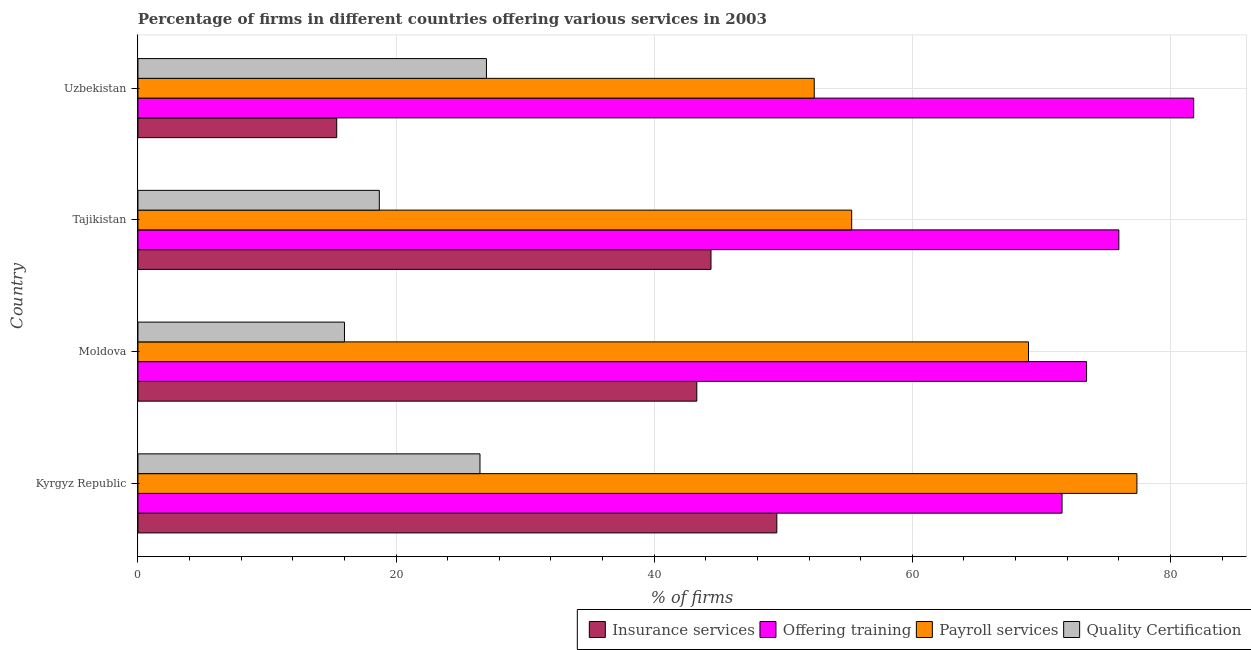How many different coloured bars are there?
Offer a very short reply. 4. Are the number of bars per tick equal to the number of legend labels?
Give a very brief answer. Yes. Are the number of bars on each tick of the Y-axis equal?
Ensure brevity in your answer.  Yes. How many bars are there on the 3rd tick from the top?
Your answer should be very brief. 4. What is the label of the 2nd group of bars from the top?
Offer a terse response. Tajikistan. What is the percentage of firms offering insurance services in Kyrgyz Republic?
Make the answer very short. 49.5. Across all countries, what is the maximum percentage of firms offering training?
Your answer should be very brief. 81.8. Across all countries, what is the minimum percentage of firms offering quality certification?
Your answer should be very brief. 16. In which country was the percentage of firms offering payroll services maximum?
Make the answer very short. Kyrgyz Republic. In which country was the percentage of firms offering training minimum?
Give a very brief answer. Kyrgyz Republic. What is the total percentage of firms offering quality certification in the graph?
Your answer should be very brief. 88.2. What is the difference between the percentage of firms offering training in Kyrgyz Republic and the percentage of firms offering quality certification in Moldova?
Offer a very short reply. 55.6. What is the average percentage of firms offering insurance services per country?
Offer a very short reply. 38.15. What is the difference between the percentage of firms offering training and percentage of firms offering quality certification in Tajikistan?
Your response must be concise. 57.3. In how many countries, is the percentage of firms offering payroll services greater than 64 %?
Your answer should be compact. 2. What is the ratio of the percentage of firms offering insurance services in Tajikistan to that in Uzbekistan?
Ensure brevity in your answer.  2.88. Is the percentage of firms offering training in Moldova less than that in Tajikistan?
Provide a short and direct response. Yes. Is the difference between the percentage of firms offering training in Kyrgyz Republic and Uzbekistan greater than the difference between the percentage of firms offering insurance services in Kyrgyz Republic and Uzbekistan?
Provide a short and direct response. No. What is the difference between the highest and the second highest percentage of firms offering insurance services?
Your response must be concise. 5.1. What does the 3rd bar from the top in Tajikistan represents?
Your answer should be very brief. Offering training. What does the 4th bar from the bottom in Moldova represents?
Offer a terse response. Quality Certification. How many bars are there?
Provide a succinct answer. 16. Are all the bars in the graph horizontal?
Your answer should be compact. Yes. How many countries are there in the graph?
Ensure brevity in your answer.  4. Are the values on the major ticks of X-axis written in scientific E-notation?
Keep it short and to the point. No. Does the graph contain any zero values?
Ensure brevity in your answer.  No. Does the graph contain grids?
Your answer should be compact. Yes. How are the legend labels stacked?
Provide a succinct answer. Horizontal. What is the title of the graph?
Keep it short and to the point. Percentage of firms in different countries offering various services in 2003. What is the label or title of the X-axis?
Provide a short and direct response. % of firms. What is the label or title of the Y-axis?
Ensure brevity in your answer.  Country. What is the % of firms of Insurance services in Kyrgyz Republic?
Give a very brief answer. 49.5. What is the % of firms in Offering training in Kyrgyz Republic?
Your answer should be compact. 71.6. What is the % of firms of Payroll services in Kyrgyz Republic?
Give a very brief answer. 77.4. What is the % of firms of Quality Certification in Kyrgyz Republic?
Ensure brevity in your answer.  26.5. What is the % of firms of Insurance services in Moldova?
Provide a short and direct response. 43.3. What is the % of firms of Offering training in Moldova?
Offer a very short reply. 73.5. What is the % of firms of Payroll services in Moldova?
Your response must be concise. 69. What is the % of firms in Quality Certification in Moldova?
Your answer should be compact. 16. What is the % of firms in Insurance services in Tajikistan?
Ensure brevity in your answer.  44.4. What is the % of firms of Offering training in Tajikistan?
Your answer should be very brief. 76. What is the % of firms of Payroll services in Tajikistan?
Provide a succinct answer. 55.3. What is the % of firms of Quality Certification in Tajikistan?
Offer a terse response. 18.7. What is the % of firms in Offering training in Uzbekistan?
Your response must be concise. 81.8. What is the % of firms of Payroll services in Uzbekistan?
Provide a short and direct response. 52.4. What is the % of firms in Quality Certification in Uzbekistan?
Provide a short and direct response. 27. Across all countries, what is the maximum % of firms of Insurance services?
Your answer should be compact. 49.5. Across all countries, what is the maximum % of firms of Offering training?
Your response must be concise. 81.8. Across all countries, what is the maximum % of firms in Payroll services?
Your answer should be very brief. 77.4. Across all countries, what is the minimum % of firms of Insurance services?
Your answer should be very brief. 15.4. Across all countries, what is the minimum % of firms in Offering training?
Your answer should be compact. 71.6. Across all countries, what is the minimum % of firms of Payroll services?
Offer a very short reply. 52.4. What is the total % of firms of Insurance services in the graph?
Make the answer very short. 152.6. What is the total % of firms of Offering training in the graph?
Ensure brevity in your answer.  302.9. What is the total % of firms in Payroll services in the graph?
Make the answer very short. 254.1. What is the total % of firms of Quality Certification in the graph?
Offer a terse response. 88.2. What is the difference between the % of firms in Insurance services in Kyrgyz Republic and that in Moldova?
Give a very brief answer. 6.2. What is the difference between the % of firms in Payroll services in Kyrgyz Republic and that in Moldova?
Your answer should be very brief. 8.4. What is the difference between the % of firms in Quality Certification in Kyrgyz Republic and that in Moldova?
Provide a succinct answer. 10.5. What is the difference between the % of firms in Insurance services in Kyrgyz Republic and that in Tajikistan?
Offer a terse response. 5.1. What is the difference between the % of firms in Offering training in Kyrgyz Republic and that in Tajikistan?
Your response must be concise. -4.4. What is the difference between the % of firms in Payroll services in Kyrgyz Republic and that in Tajikistan?
Your response must be concise. 22.1. What is the difference between the % of firms in Quality Certification in Kyrgyz Republic and that in Tajikistan?
Ensure brevity in your answer.  7.8. What is the difference between the % of firms in Insurance services in Kyrgyz Republic and that in Uzbekistan?
Your answer should be compact. 34.1. What is the difference between the % of firms in Insurance services in Moldova and that in Tajikistan?
Offer a terse response. -1.1. What is the difference between the % of firms of Insurance services in Moldova and that in Uzbekistan?
Your answer should be very brief. 27.9. What is the difference between the % of firms in Payroll services in Tajikistan and that in Uzbekistan?
Keep it short and to the point. 2.9. What is the difference between the % of firms of Insurance services in Kyrgyz Republic and the % of firms of Payroll services in Moldova?
Ensure brevity in your answer.  -19.5. What is the difference between the % of firms of Insurance services in Kyrgyz Republic and the % of firms of Quality Certification in Moldova?
Keep it short and to the point. 33.5. What is the difference between the % of firms of Offering training in Kyrgyz Republic and the % of firms of Payroll services in Moldova?
Provide a succinct answer. 2.6. What is the difference between the % of firms in Offering training in Kyrgyz Republic and the % of firms in Quality Certification in Moldova?
Your answer should be very brief. 55.6. What is the difference between the % of firms in Payroll services in Kyrgyz Republic and the % of firms in Quality Certification in Moldova?
Your answer should be very brief. 61.4. What is the difference between the % of firms of Insurance services in Kyrgyz Republic and the % of firms of Offering training in Tajikistan?
Make the answer very short. -26.5. What is the difference between the % of firms of Insurance services in Kyrgyz Republic and the % of firms of Payroll services in Tajikistan?
Offer a very short reply. -5.8. What is the difference between the % of firms in Insurance services in Kyrgyz Republic and the % of firms in Quality Certification in Tajikistan?
Your answer should be very brief. 30.8. What is the difference between the % of firms of Offering training in Kyrgyz Republic and the % of firms of Quality Certification in Tajikistan?
Offer a very short reply. 52.9. What is the difference between the % of firms in Payroll services in Kyrgyz Republic and the % of firms in Quality Certification in Tajikistan?
Your answer should be very brief. 58.7. What is the difference between the % of firms of Insurance services in Kyrgyz Republic and the % of firms of Offering training in Uzbekistan?
Give a very brief answer. -32.3. What is the difference between the % of firms in Offering training in Kyrgyz Republic and the % of firms in Quality Certification in Uzbekistan?
Your answer should be very brief. 44.6. What is the difference between the % of firms in Payroll services in Kyrgyz Republic and the % of firms in Quality Certification in Uzbekistan?
Make the answer very short. 50.4. What is the difference between the % of firms of Insurance services in Moldova and the % of firms of Offering training in Tajikistan?
Provide a succinct answer. -32.7. What is the difference between the % of firms in Insurance services in Moldova and the % of firms in Quality Certification in Tajikistan?
Ensure brevity in your answer.  24.6. What is the difference between the % of firms of Offering training in Moldova and the % of firms of Quality Certification in Tajikistan?
Your answer should be very brief. 54.8. What is the difference between the % of firms of Payroll services in Moldova and the % of firms of Quality Certification in Tajikistan?
Your answer should be compact. 50.3. What is the difference between the % of firms of Insurance services in Moldova and the % of firms of Offering training in Uzbekistan?
Provide a succinct answer. -38.5. What is the difference between the % of firms of Insurance services in Moldova and the % of firms of Payroll services in Uzbekistan?
Provide a succinct answer. -9.1. What is the difference between the % of firms of Insurance services in Moldova and the % of firms of Quality Certification in Uzbekistan?
Your answer should be very brief. 16.3. What is the difference between the % of firms of Offering training in Moldova and the % of firms of Payroll services in Uzbekistan?
Give a very brief answer. 21.1. What is the difference between the % of firms of Offering training in Moldova and the % of firms of Quality Certification in Uzbekistan?
Offer a very short reply. 46.5. What is the difference between the % of firms of Payroll services in Moldova and the % of firms of Quality Certification in Uzbekistan?
Offer a very short reply. 42. What is the difference between the % of firms of Insurance services in Tajikistan and the % of firms of Offering training in Uzbekistan?
Provide a short and direct response. -37.4. What is the difference between the % of firms of Insurance services in Tajikistan and the % of firms of Payroll services in Uzbekistan?
Give a very brief answer. -8. What is the difference between the % of firms of Insurance services in Tajikistan and the % of firms of Quality Certification in Uzbekistan?
Your answer should be very brief. 17.4. What is the difference between the % of firms of Offering training in Tajikistan and the % of firms of Payroll services in Uzbekistan?
Make the answer very short. 23.6. What is the difference between the % of firms of Offering training in Tajikistan and the % of firms of Quality Certification in Uzbekistan?
Offer a terse response. 49. What is the difference between the % of firms of Payroll services in Tajikistan and the % of firms of Quality Certification in Uzbekistan?
Make the answer very short. 28.3. What is the average % of firms of Insurance services per country?
Offer a terse response. 38.15. What is the average % of firms of Offering training per country?
Your answer should be compact. 75.72. What is the average % of firms in Payroll services per country?
Offer a terse response. 63.52. What is the average % of firms in Quality Certification per country?
Provide a succinct answer. 22.05. What is the difference between the % of firms of Insurance services and % of firms of Offering training in Kyrgyz Republic?
Provide a succinct answer. -22.1. What is the difference between the % of firms in Insurance services and % of firms in Payroll services in Kyrgyz Republic?
Ensure brevity in your answer.  -27.9. What is the difference between the % of firms in Offering training and % of firms in Quality Certification in Kyrgyz Republic?
Provide a succinct answer. 45.1. What is the difference between the % of firms of Payroll services and % of firms of Quality Certification in Kyrgyz Republic?
Keep it short and to the point. 50.9. What is the difference between the % of firms in Insurance services and % of firms in Offering training in Moldova?
Provide a short and direct response. -30.2. What is the difference between the % of firms in Insurance services and % of firms in Payroll services in Moldova?
Offer a very short reply. -25.7. What is the difference between the % of firms of Insurance services and % of firms of Quality Certification in Moldova?
Offer a very short reply. 27.3. What is the difference between the % of firms in Offering training and % of firms in Quality Certification in Moldova?
Make the answer very short. 57.5. What is the difference between the % of firms in Payroll services and % of firms in Quality Certification in Moldova?
Give a very brief answer. 53. What is the difference between the % of firms in Insurance services and % of firms in Offering training in Tajikistan?
Offer a terse response. -31.6. What is the difference between the % of firms in Insurance services and % of firms in Quality Certification in Tajikistan?
Ensure brevity in your answer.  25.7. What is the difference between the % of firms of Offering training and % of firms of Payroll services in Tajikistan?
Offer a terse response. 20.7. What is the difference between the % of firms of Offering training and % of firms of Quality Certification in Tajikistan?
Keep it short and to the point. 57.3. What is the difference between the % of firms in Payroll services and % of firms in Quality Certification in Tajikistan?
Your answer should be very brief. 36.6. What is the difference between the % of firms in Insurance services and % of firms in Offering training in Uzbekistan?
Keep it short and to the point. -66.4. What is the difference between the % of firms of Insurance services and % of firms of Payroll services in Uzbekistan?
Provide a short and direct response. -37. What is the difference between the % of firms in Offering training and % of firms in Payroll services in Uzbekistan?
Offer a very short reply. 29.4. What is the difference between the % of firms in Offering training and % of firms in Quality Certification in Uzbekistan?
Give a very brief answer. 54.8. What is the difference between the % of firms of Payroll services and % of firms of Quality Certification in Uzbekistan?
Your answer should be very brief. 25.4. What is the ratio of the % of firms in Insurance services in Kyrgyz Republic to that in Moldova?
Your answer should be compact. 1.14. What is the ratio of the % of firms of Offering training in Kyrgyz Republic to that in Moldova?
Your response must be concise. 0.97. What is the ratio of the % of firms in Payroll services in Kyrgyz Republic to that in Moldova?
Your answer should be compact. 1.12. What is the ratio of the % of firms of Quality Certification in Kyrgyz Republic to that in Moldova?
Your response must be concise. 1.66. What is the ratio of the % of firms in Insurance services in Kyrgyz Republic to that in Tajikistan?
Provide a succinct answer. 1.11. What is the ratio of the % of firms in Offering training in Kyrgyz Republic to that in Tajikistan?
Your answer should be very brief. 0.94. What is the ratio of the % of firms of Payroll services in Kyrgyz Republic to that in Tajikistan?
Your response must be concise. 1.4. What is the ratio of the % of firms in Quality Certification in Kyrgyz Republic to that in Tajikistan?
Offer a very short reply. 1.42. What is the ratio of the % of firms of Insurance services in Kyrgyz Republic to that in Uzbekistan?
Offer a very short reply. 3.21. What is the ratio of the % of firms of Offering training in Kyrgyz Republic to that in Uzbekistan?
Your answer should be compact. 0.88. What is the ratio of the % of firms in Payroll services in Kyrgyz Republic to that in Uzbekistan?
Your answer should be compact. 1.48. What is the ratio of the % of firms of Quality Certification in Kyrgyz Republic to that in Uzbekistan?
Offer a terse response. 0.98. What is the ratio of the % of firms in Insurance services in Moldova to that in Tajikistan?
Offer a very short reply. 0.98. What is the ratio of the % of firms in Offering training in Moldova to that in Tajikistan?
Offer a very short reply. 0.97. What is the ratio of the % of firms of Payroll services in Moldova to that in Tajikistan?
Make the answer very short. 1.25. What is the ratio of the % of firms of Quality Certification in Moldova to that in Tajikistan?
Provide a succinct answer. 0.86. What is the ratio of the % of firms of Insurance services in Moldova to that in Uzbekistan?
Offer a very short reply. 2.81. What is the ratio of the % of firms of Offering training in Moldova to that in Uzbekistan?
Offer a terse response. 0.9. What is the ratio of the % of firms of Payroll services in Moldova to that in Uzbekistan?
Make the answer very short. 1.32. What is the ratio of the % of firms in Quality Certification in Moldova to that in Uzbekistan?
Ensure brevity in your answer.  0.59. What is the ratio of the % of firms of Insurance services in Tajikistan to that in Uzbekistan?
Keep it short and to the point. 2.88. What is the ratio of the % of firms in Offering training in Tajikistan to that in Uzbekistan?
Your response must be concise. 0.93. What is the ratio of the % of firms in Payroll services in Tajikistan to that in Uzbekistan?
Keep it short and to the point. 1.06. What is the ratio of the % of firms of Quality Certification in Tajikistan to that in Uzbekistan?
Make the answer very short. 0.69. What is the difference between the highest and the second highest % of firms in Insurance services?
Keep it short and to the point. 5.1. What is the difference between the highest and the second highest % of firms in Offering training?
Ensure brevity in your answer.  5.8. What is the difference between the highest and the second highest % of firms of Payroll services?
Provide a succinct answer. 8.4. What is the difference between the highest and the second highest % of firms in Quality Certification?
Offer a very short reply. 0.5. What is the difference between the highest and the lowest % of firms in Insurance services?
Provide a short and direct response. 34.1. What is the difference between the highest and the lowest % of firms in Payroll services?
Your response must be concise. 25. 